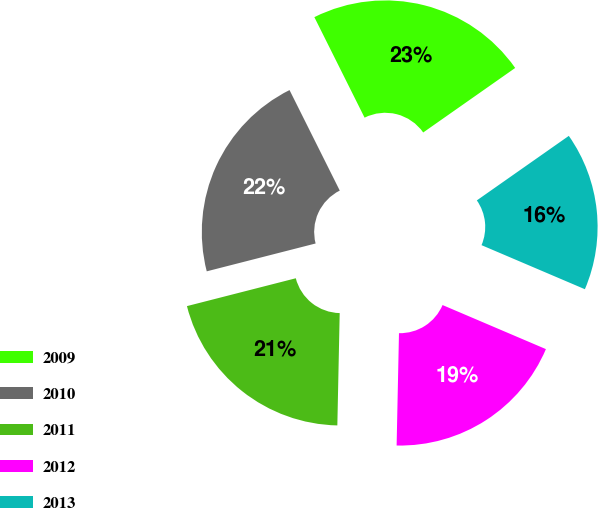Convert chart to OTSL. <chart><loc_0><loc_0><loc_500><loc_500><pie_chart><fcel>2009<fcel>2010<fcel>2011<fcel>2012<fcel>2013<nl><fcel>22.64%<fcel>21.61%<fcel>20.68%<fcel>18.92%<fcel>16.15%<nl></chart> 